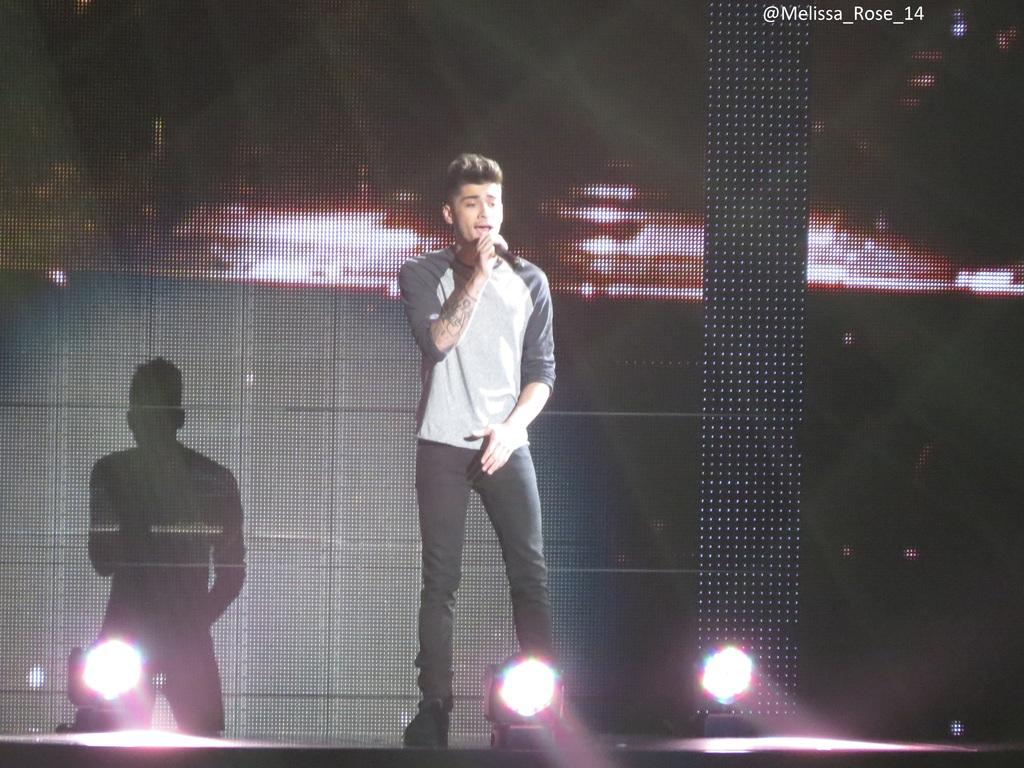What is the person in the image doing? The person is standing in the image and holding a mic. What is the person wearing? The person is wearing a black and white color dress. What can be seen in the background of the image? There is a screen and lights visible in the background. What type of insurance policy does the person in the image have? There is no information about insurance policies in the image, as it focuses on the person holding a mic and their attire. 